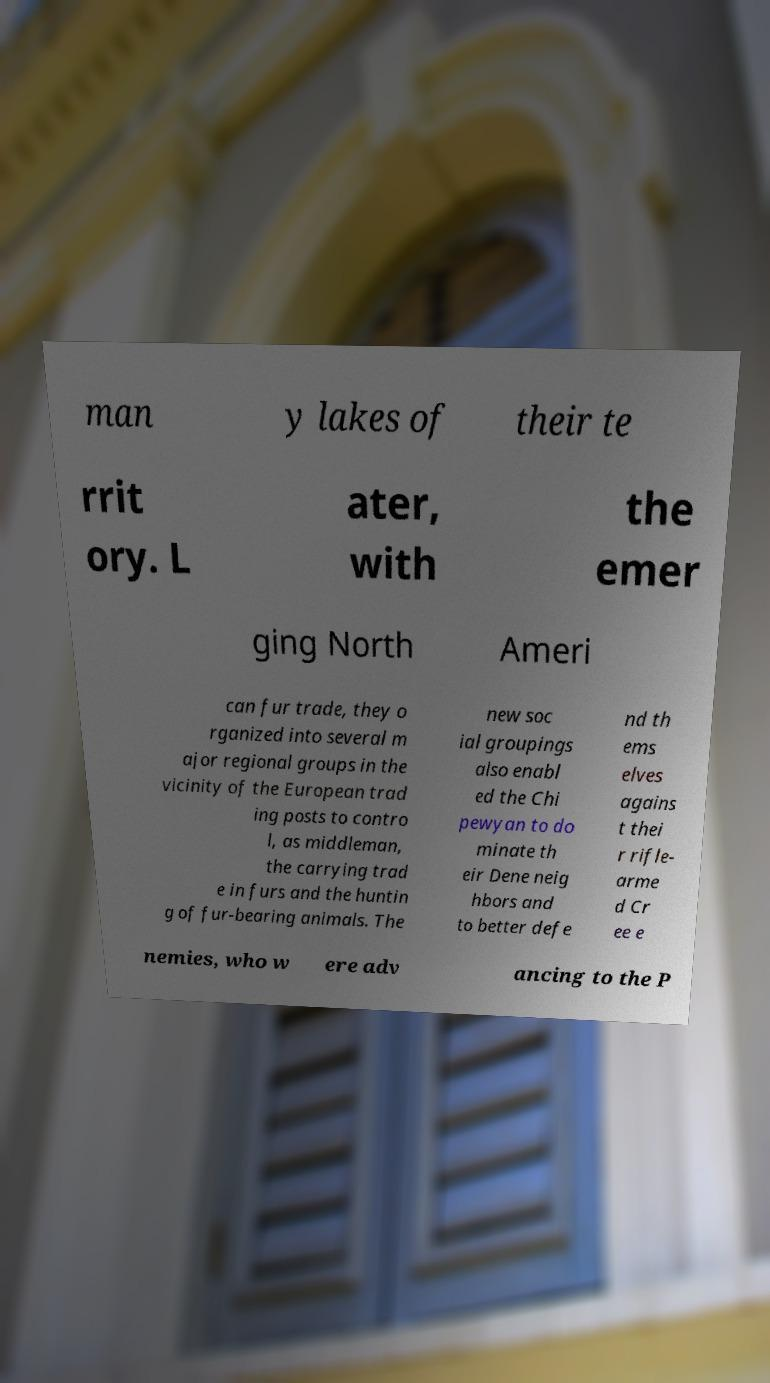Please identify and transcribe the text found in this image. man y lakes of their te rrit ory. L ater, with the emer ging North Ameri can fur trade, they o rganized into several m ajor regional groups in the vicinity of the European trad ing posts to contro l, as middleman, the carrying trad e in furs and the huntin g of fur-bearing animals. The new soc ial groupings also enabl ed the Chi pewyan to do minate th eir Dene neig hbors and to better defe nd th ems elves agains t thei r rifle- arme d Cr ee e nemies, who w ere adv ancing to the P 